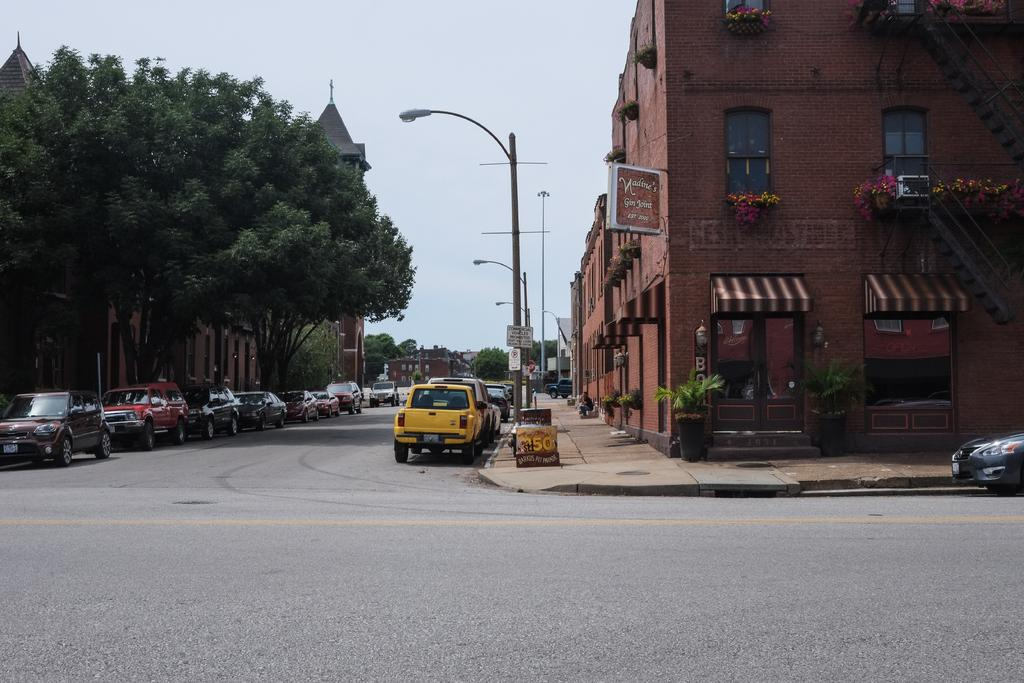What types of structures can be seen in the image? There are buildings in the image. What else can be seen in the image besides buildings? There are vehicles, trees, poles, lights, boards, house plants, and windows visible in the image. What is the background of the image? The sky is visible in the background of the image. Can you tell me what type of toothbrush the tiger is using in the image? There is no toothbrush or tiger present in the image. 